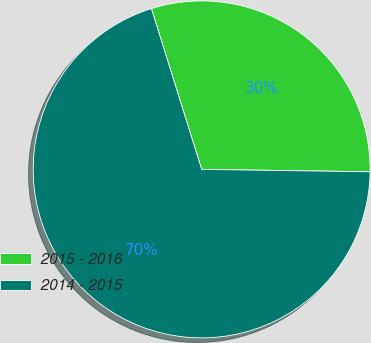Convert chart to OTSL. <chart><loc_0><loc_0><loc_500><loc_500><pie_chart><fcel>2015 - 2016<fcel>2014 - 2015<nl><fcel>30.05%<fcel>69.95%<nl></chart> 